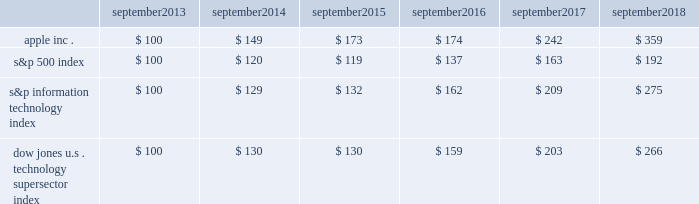Apple inc .
| 2018 form 10-k | 20 company stock performance the following graph shows a comparison of cumulative total shareholder return , calculated on a dividend-reinvested basis , for the company , the s&p 500 index , the s&p information technology index and the dow jones u.s .
Technology supersector index for the five years ended september 29 , 2018 .
The graph assumes $ 100 was invested in each of the company 2019s common stock , the s&p 500 index , the s&p information technology index and the dow jones u.s .
Technology supersector index as of the market close on september 27 , 2013 .
Note that historic stock price performance is not necessarily indicative of future stock price performance .
* $ 100 invested on september 27 , 2013 in stock or index , including reinvestment of dividends .
Data points are the last day of each fiscal year for the company 2019s common stock and september 30th for indexes .
Copyright a9 2018 standard & poor 2019s , a division of s&p global .
All rights reserved .
Copyright a9 2018 s&p dow jones indices llc , a division of s&p global .
All rights reserved .
September september september september september september .

Did apple outperform ( earn a greater return ) than the s&p information technology index in september 2018? 
Computations: (359 > 275)
Answer: yes. Apple inc .
| 2018 form 10-k | 20 company stock performance the following graph shows a comparison of cumulative total shareholder return , calculated on a dividend-reinvested basis , for the company , the s&p 500 index , the s&p information technology index and the dow jones u.s .
Technology supersector index for the five years ended september 29 , 2018 .
The graph assumes $ 100 was invested in each of the company 2019s common stock , the s&p 500 index , the s&p information technology index and the dow jones u.s .
Technology supersector index as of the market close on september 27 , 2013 .
Note that historic stock price performance is not necessarily indicative of future stock price performance .
* $ 100 invested on september 27 , 2013 in stock or index , including reinvestment of dividends .
Data points are the last day of each fiscal year for the company 2019s common stock and september 30th for indexes .
Copyright a9 2018 standard & poor 2019s , a division of s&p global .
All rights reserved .
Copyright a9 2018 s&p dow jones indices llc , a division of s&p global .
All rights reserved .
September september september september september september .

Did apple outperform ( earn a greater return ) than the s&p information technology index in september 2014? 
Computations: (149 > 129)
Answer: yes. 